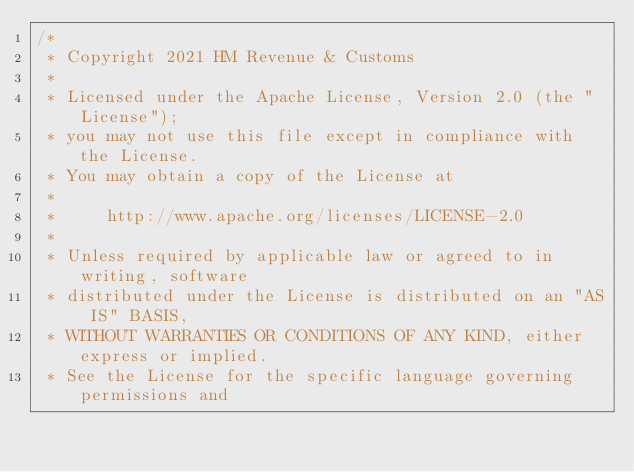Convert code to text. <code><loc_0><loc_0><loc_500><loc_500><_Scala_>/*
 * Copyright 2021 HM Revenue & Customs
 *
 * Licensed under the Apache License, Version 2.0 (the "License");
 * you may not use this file except in compliance with the License.
 * You may obtain a copy of the License at
 *
 *     http://www.apache.org/licenses/LICENSE-2.0
 *
 * Unless required by applicable law or agreed to in writing, software
 * distributed under the License is distributed on an "AS IS" BASIS,
 * WITHOUT WARRANTIES OR CONDITIONS OF ANY KIND, either express or implied.
 * See the License for the specific language governing permissions and</code> 